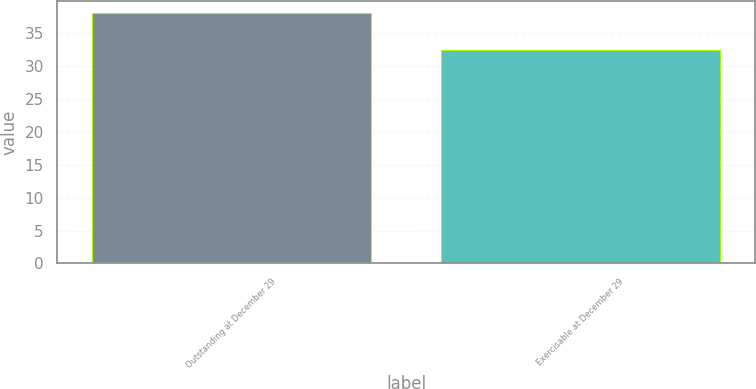<chart> <loc_0><loc_0><loc_500><loc_500><bar_chart><fcel>Outstanding at December 29<fcel>Exercisable at December 29<nl><fcel>37.98<fcel>32.4<nl></chart> 